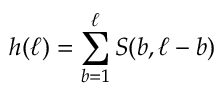<formula> <loc_0><loc_0><loc_500><loc_500>h ( \ell ) = \sum _ { b = 1 } ^ { \ell } S ( b , \ell - b )</formula> 